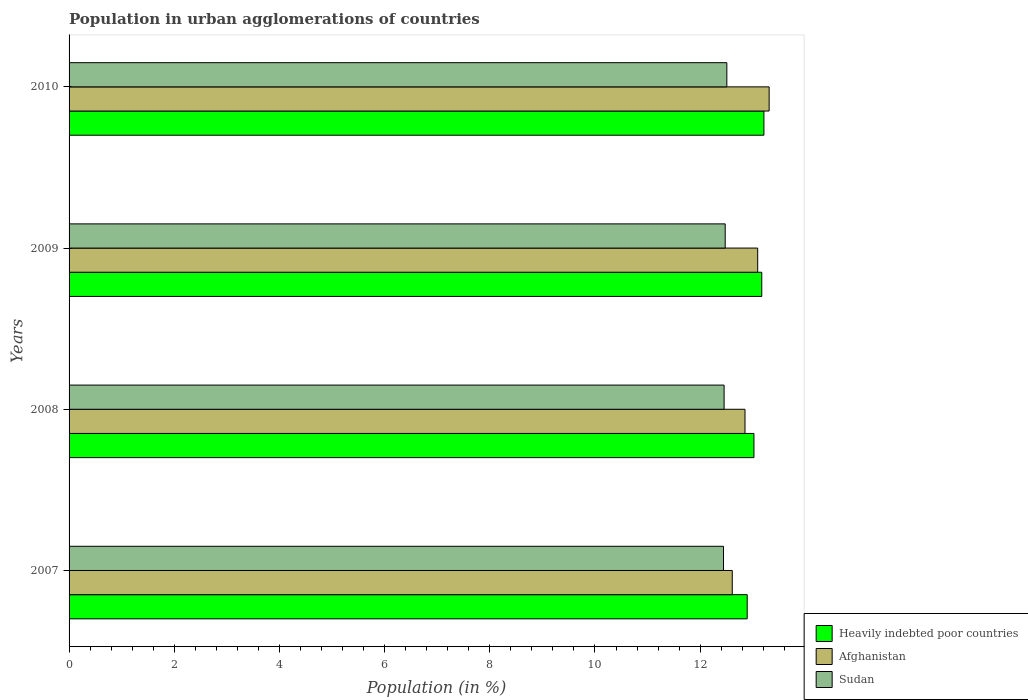Are the number of bars per tick equal to the number of legend labels?
Your answer should be very brief. Yes. How many bars are there on the 2nd tick from the top?
Your answer should be very brief. 3. What is the percentage of population in urban agglomerations in Heavily indebted poor countries in 2007?
Offer a very short reply. 12.89. Across all years, what is the maximum percentage of population in urban agglomerations in Afghanistan?
Your answer should be compact. 13.31. Across all years, what is the minimum percentage of population in urban agglomerations in Afghanistan?
Offer a very short reply. 12.61. In which year was the percentage of population in urban agglomerations in Heavily indebted poor countries maximum?
Your answer should be very brief. 2010. In which year was the percentage of population in urban agglomerations in Sudan minimum?
Provide a succinct answer. 2007. What is the total percentage of population in urban agglomerations in Heavily indebted poor countries in the graph?
Make the answer very short. 52.3. What is the difference between the percentage of population in urban agglomerations in Afghanistan in 2007 and that in 2008?
Give a very brief answer. -0.24. What is the difference between the percentage of population in urban agglomerations in Sudan in 2009 and the percentage of population in urban agglomerations in Afghanistan in 2008?
Make the answer very short. -0.38. What is the average percentage of population in urban agglomerations in Sudan per year?
Your response must be concise. 12.47. In the year 2009, what is the difference between the percentage of population in urban agglomerations in Sudan and percentage of population in urban agglomerations in Heavily indebted poor countries?
Offer a terse response. -0.7. What is the ratio of the percentage of population in urban agglomerations in Heavily indebted poor countries in 2008 to that in 2009?
Keep it short and to the point. 0.99. Is the percentage of population in urban agglomerations in Afghanistan in 2007 less than that in 2009?
Offer a terse response. Yes. Is the difference between the percentage of population in urban agglomerations in Sudan in 2008 and 2010 greater than the difference between the percentage of population in urban agglomerations in Heavily indebted poor countries in 2008 and 2010?
Make the answer very short. Yes. What is the difference between the highest and the second highest percentage of population in urban agglomerations in Afghanistan?
Your answer should be compact. 0.22. What is the difference between the highest and the lowest percentage of population in urban agglomerations in Afghanistan?
Make the answer very short. 0.7. What does the 2nd bar from the top in 2009 represents?
Offer a terse response. Afghanistan. What does the 3rd bar from the bottom in 2008 represents?
Give a very brief answer. Sudan. How many bars are there?
Make the answer very short. 12. How many years are there in the graph?
Offer a terse response. 4. Does the graph contain any zero values?
Provide a short and direct response. No. Does the graph contain grids?
Offer a terse response. No. How are the legend labels stacked?
Provide a short and direct response. Vertical. What is the title of the graph?
Offer a very short reply. Population in urban agglomerations of countries. What is the label or title of the X-axis?
Your answer should be very brief. Population (in %). What is the Population (in %) of Heavily indebted poor countries in 2007?
Offer a very short reply. 12.89. What is the Population (in %) in Afghanistan in 2007?
Keep it short and to the point. 12.61. What is the Population (in %) in Sudan in 2007?
Your answer should be very brief. 12.44. What is the Population (in %) in Heavily indebted poor countries in 2008?
Provide a short and direct response. 13.02. What is the Population (in %) in Afghanistan in 2008?
Your answer should be compact. 12.85. What is the Population (in %) of Sudan in 2008?
Ensure brevity in your answer.  12.46. What is the Population (in %) in Heavily indebted poor countries in 2009?
Keep it short and to the point. 13.17. What is the Population (in %) in Afghanistan in 2009?
Offer a terse response. 13.09. What is the Population (in %) of Sudan in 2009?
Make the answer very short. 12.48. What is the Population (in %) in Heavily indebted poor countries in 2010?
Your answer should be compact. 13.21. What is the Population (in %) of Afghanistan in 2010?
Offer a very short reply. 13.31. What is the Population (in %) in Sudan in 2010?
Your response must be concise. 12.51. Across all years, what is the maximum Population (in %) in Heavily indebted poor countries?
Offer a terse response. 13.21. Across all years, what is the maximum Population (in %) in Afghanistan?
Your answer should be compact. 13.31. Across all years, what is the maximum Population (in %) of Sudan?
Your response must be concise. 12.51. Across all years, what is the minimum Population (in %) in Heavily indebted poor countries?
Offer a terse response. 12.89. Across all years, what is the minimum Population (in %) of Afghanistan?
Offer a very short reply. 12.61. Across all years, what is the minimum Population (in %) in Sudan?
Ensure brevity in your answer.  12.44. What is the total Population (in %) in Heavily indebted poor countries in the graph?
Your answer should be compact. 52.3. What is the total Population (in %) of Afghanistan in the graph?
Your response must be concise. 51.87. What is the total Population (in %) in Sudan in the graph?
Make the answer very short. 49.88. What is the difference between the Population (in %) of Heavily indebted poor countries in 2007 and that in 2008?
Your answer should be very brief. -0.13. What is the difference between the Population (in %) of Afghanistan in 2007 and that in 2008?
Your response must be concise. -0.24. What is the difference between the Population (in %) of Sudan in 2007 and that in 2008?
Offer a terse response. -0.01. What is the difference between the Population (in %) in Heavily indebted poor countries in 2007 and that in 2009?
Provide a short and direct response. -0.28. What is the difference between the Population (in %) of Afghanistan in 2007 and that in 2009?
Keep it short and to the point. -0.48. What is the difference between the Population (in %) in Sudan in 2007 and that in 2009?
Your answer should be compact. -0.03. What is the difference between the Population (in %) in Heavily indebted poor countries in 2007 and that in 2010?
Keep it short and to the point. -0.32. What is the difference between the Population (in %) in Afghanistan in 2007 and that in 2010?
Your answer should be very brief. -0.7. What is the difference between the Population (in %) of Sudan in 2007 and that in 2010?
Give a very brief answer. -0.06. What is the difference between the Population (in %) in Heavily indebted poor countries in 2008 and that in 2009?
Your response must be concise. -0.15. What is the difference between the Population (in %) of Afghanistan in 2008 and that in 2009?
Offer a terse response. -0.24. What is the difference between the Population (in %) of Sudan in 2008 and that in 2009?
Provide a short and direct response. -0.02. What is the difference between the Population (in %) of Heavily indebted poor countries in 2008 and that in 2010?
Ensure brevity in your answer.  -0.19. What is the difference between the Population (in %) in Afghanistan in 2008 and that in 2010?
Give a very brief answer. -0.46. What is the difference between the Population (in %) of Sudan in 2008 and that in 2010?
Give a very brief answer. -0.05. What is the difference between the Population (in %) in Heavily indebted poor countries in 2009 and that in 2010?
Offer a terse response. -0.04. What is the difference between the Population (in %) of Afghanistan in 2009 and that in 2010?
Make the answer very short. -0.22. What is the difference between the Population (in %) of Sudan in 2009 and that in 2010?
Provide a succinct answer. -0.03. What is the difference between the Population (in %) in Heavily indebted poor countries in 2007 and the Population (in %) in Afghanistan in 2008?
Give a very brief answer. 0.04. What is the difference between the Population (in %) in Heavily indebted poor countries in 2007 and the Population (in %) in Sudan in 2008?
Provide a short and direct response. 0.44. What is the difference between the Population (in %) of Afghanistan in 2007 and the Population (in %) of Sudan in 2008?
Provide a short and direct response. 0.15. What is the difference between the Population (in %) in Heavily indebted poor countries in 2007 and the Population (in %) in Afghanistan in 2009?
Offer a terse response. -0.2. What is the difference between the Population (in %) of Heavily indebted poor countries in 2007 and the Population (in %) of Sudan in 2009?
Ensure brevity in your answer.  0.42. What is the difference between the Population (in %) of Afghanistan in 2007 and the Population (in %) of Sudan in 2009?
Your answer should be compact. 0.13. What is the difference between the Population (in %) in Heavily indebted poor countries in 2007 and the Population (in %) in Afghanistan in 2010?
Keep it short and to the point. -0.42. What is the difference between the Population (in %) in Heavily indebted poor countries in 2007 and the Population (in %) in Sudan in 2010?
Keep it short and to the point. 0.39. What is the difference between the Population (in %) in Afghanistan in 2007 and the Population (in %) in Sudan in 2010?
Your response must be concise. 0.1. What is the difference between the Population (in %) of Heavily indebted poor countries in 2008 and the Population (in %) of Afghanistan in 2009?
Your answer should be very brief. -0.07. What is the difference between the Population (in %) of Heavily indebted poor countries in 2008 and the Population (in %) of Sudan in 2009?
Make the answer very short. 0.55. What is the difference between the Population (in %) in Afghanistan in 2008 and the Population (in %) in Sudan in 2009?
Your answer should be very brief. 0.38. What is the difference between the Population (in %) of Heavily indebted poor countries in 2008 and the Population (in %) of Afghanistan in 2010?
Make the answer very short. -0.29. What is the difference between the Population (in %) of Heavily indebted poor countries in 2008 and the Population (in %) of Sudan in 2010?
Offer a terse response. 0.52. What is the difference between the Population (in %) in Afghanistan in 2008 and the Population (in %) in Sudan in 2010?
Your response must be concise. 0.35. What is the difference between the Population (in %) of Heavily indebted poor countries in 2009 and the Population (in %) of Afghanistan in 2010?
Keep it short and to the point. -0.14. What is the difference between the Population (in %) of Heavily indebted poor countries in 2009 and the Population (in %) of Sudan in 2010?
Offer a terse response. 0.66. What is the difference between the Population (in %) in Afghanistan in 2009 and the Population (in %) in Sudan in 2010?
Provide a succinct answer. 0.59. What is the average Population (in %) in Heavily indebted poor countries per year?
Make the answer very short. 13.08. What is the average Population (in %) of Afghanistan per year?
Your answer should be compact. 12.97. What is the average Population (in %) in Sudan per year?
Provide a succinct answer. 12.47. In the year 2007, what is the difference between the Population (in %) of Heavily indebted poor countries and Population (in %) of Afghanistan?
Provide a succinct answer. 0.28. In the year 2007, what is the difference between the Population (in %) of Heavily indebted poor countries and Population (in %) of Sudan?
Your response must be concise. 0.45. In the year 2007, what is the difference between the Population (in %) of Afghanistan and Population (in %) of Sudan?
Offer a very short reply. 0.17. In the year 2008, what is the difference between the Population (in %) of Heavily indebted poor countries and Population (in %) of Afghanistan?
Offer a very short reply. 0.17. In the year 2008, what is the difference between the Population (in %) in Heavily indebted poor countries and Population (in %) in Sudan?
Ensure brevity in your answer.  0.57. In the year 2008, what is the difference between the Population (in %) of Afghanistan and Population (in %) of Sudan?
Make the answer very short. 0.4. In the year 2009, what is the difference between the Population (in %) in Heavily indebted poor countries and Population (in %) in Afghanistan?
Your answer should be very brief. 0.08. In the year 2009, what is the difference between the Population (in %) in Heavily indebted poor countries and Population (in %) in Sudan?
Your response must be concise. 0.7. In the year 2009, what is the difference between the Population (in %) in Afghanistan and Population (in %) in Sudan?
Give a very brief answer. 0.62. In the year 2010, what is the difference between the Population (in %) in Heavily indebted poor countries and Population (in %) in Afghanistan?
Offer a very short reply. -0.1. In the year 2010, what is the difference between the Population (in %) of Heavily indebted poor countries and Population (in %) of Sudan?
Your response must be concise. 0.71. In the year 2010, what is the difference between the Population (in %) of Afghanistan and Population (in %) of Sudan?
Provide a short and direct response. 0.8. What is the ratio of the Population (in %) in Heavily indebted poor countries in 2007 to that in 2008?
Keep it short and to the point. 0.99. What is the ratio of the Population (in %) in Afghanistan in 2007 to that in 2008?
Provide a succinct answer. 0.98. What is the ratio of the Population (in %) of Sudan in 2007 to that in 2008?
Offer a very short reply. 1. What is the ratio of the Population (in %) of Afghanistan in 2007 to that in 2009?
Give a very brief answer. 0.96. What is the ratio of the Population (in %) in Sudan in 2007 to that in 2009?
Give a very brief answer. 1. What is the ratio of the Population (in %) of Heavily indebted poor countries in 2007 to that in 2010?
Provide a short and direct response. 0.98. What is the ratio of the Population (in %) of Afghanistan in 2007 to that in 2010?
Offer a very short reply. 0.95. What is the ratio of the Population (in %) in Heavily indebted poor countries in 2008 to that in 2009?
Offer a very short reply. 0.99. What is the ratio of the Population (in %) of Afghanistan in 2008 to that in 2009?
Your response must be concise. 0.98. What is the ratio of the Population (in %) in Sudan in 2008 to that in 2009?
Your answer should be very brief. 1. What is the ratio of the Population (in %) in Heavily indebted poor countries in 2008 to that in 2010?
Your response must be concise. 0.99. What is the ratio of the Population (in %) in Afghanistan in 2008 to that in 2010?
Offer a terse response. 0.97. What is the ratio of the Population (in %) in Afghanistan in 2009 to that in 2010?
Make the answer very short. 0.98. What is the ratio of the Population (in %) in Sudan in 2009 to that in 2010?
Offer a very short reply. 1. What is the difference between the highest and the second highest Population (in %) of Heavily indebted poor countries?
Your response must be concise. 0.04. What is the difference between the highest and the second highest Population (in %) in Afghanistan?
Give a very brief answer. 0.22. What is the difference between the highest and the second highest Population (in %) of Sudan?
Your answer should be very brief. 0.03. What is the difference between the highest and the lowest Population (in %) of Heavily indebted poor countries?
Your answer should be compact. 0.32. What is the difference between the highest and the lowest Population (in %) in Afghanistan?
Your answer should be very brief. 0.7. What is the difference between the highest and the lowest Population (in %) in Sudan?
Offer a terse response. 0.06. 